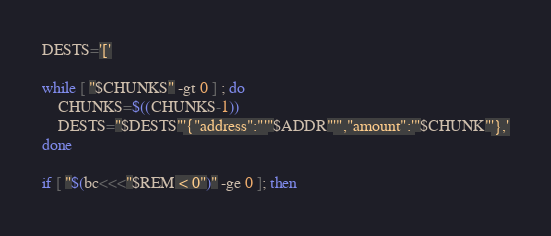<code> <loc_0><loc_0><loc_500><loc_500><_Bash_>DESTS='['

while [ "$CHUNKS" -gt 0 ] ; do
	CHUNKS=$((CHUNKS-1))
	DESTS="$DESTS"'{"address":"'"$ADDR"'","amount":'"$CHUNK"'},'
done

if [ "$(bc<<<"$REM < 0")" -ge 0 ]; then</code> 